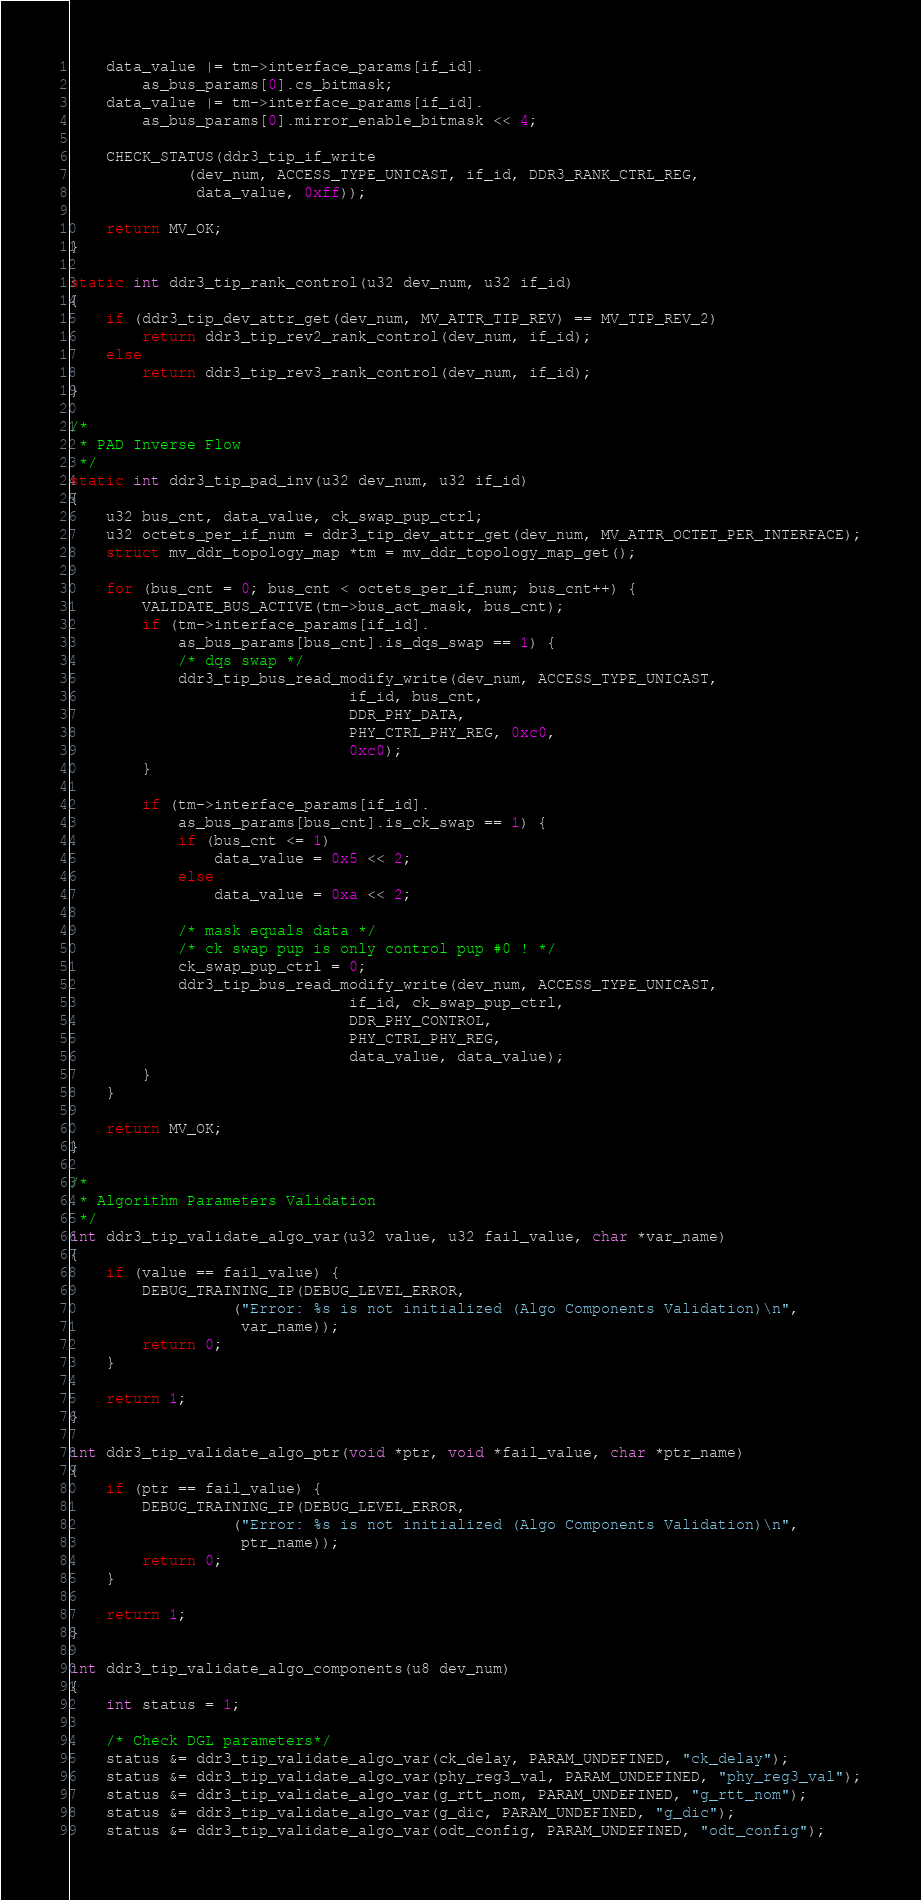<code> <loc_0><loc_0><loc_500><loc_500><_C_>	data_value |= tm->interface_params[if_id].
		as_bus_params[0].cs_bitmask;
	data_value |= tm->interface_params[if_id].
		as_bus_params[0].mirror_enable_bitmask << 4;

	CHECK_STATUS(ddr3_tip_if_write
		     (dev_num, ACCESS_TYPE_UNICAST, if_id, DDR3_RANK_CTRL_REG,
		      data_value, 0xff));

	return MV_OK;
}

static int ddr3_tip_rank_control(u32 dev_num, u32 if_id)
{
	if (ddr3_tip_dev_attr_get(dev_num, MV_ATTR_TIP_REV) == MV_TIP_REV_2)
		return ddr3_tip_rev2_rank_control(dev_num, if_id);
	else
		return ddr3_tip_rev3_rank_control(dev_num, if_id);
}

/*
 * PAD Inverse Flow
 */
static int ddr3_tip_pad_inv(u32 dev_num, u32 if_id)
{
	u32 bus_cnt, data_value, ck_swap_pup_ctrl;
	u32 octets_per_if_num = ddr3_tip_dev_attr_get(dev_num, MV_ATTR_OCTET_PER_INTERFACE);
	struct mv_ddr_topology_map *tm = mv_ddr_topology_map_get();

	for (bus_cnt = 0; bus_cnt < octets_per_if_num; bus_cnt++) {
		VALIDATE_BUS_ACTIVE(tm->bus_act_mask, bus_cnt);
		if (tm->interface_params[if_id].
		    as_bus_params[bus_cnt].is_dqs_swap == 1) {
			/* dqs swap */
			ddr3_tip_bus_read_modify_write(dev_num, ACCESS_TYPE_UNICAST,
						       if_id, bus_cnt,
						       DDR_PHY_DATA,
						       PHY_CTRL_PHY_REG, 0xc0,
						       0xc0);
		}

		if (tm->interface_params[if_id].
		    as_bus_params[bus_cnt].is_ck_swap == 1) {
			if (bus_cnt <= 1)
				data_value = 0x5 << 2;
			else
				data_value = 0xa << 2;

			/* mask equals data */
			/* ck swap pup is only control pup #0 ! */
			ck_swap_pup_ctrl = 0;
			ddr3_tip_bus_read_modify_write(dev_num, ACCESS_TYPE_UNICAST,
						       if_id, ck_swap_pup_ctrl,
						       DDR_PHY_CONTROL,
						       PHY_CTRL_PHY_REG,
						       data_value, data_value);
		}
	}

	return MV_OK;
}

/*
 * Algorithm Parameters Validation
 */
int ddr3_tip_validate_algo_var(u32 value, u32 fail_value, char *var_name)
{
	if (value == fail_value) {
		DEBUG_TRAINING_IP(DEBUG_LEVEL_ERROR,
				  ("Error: %s is not initialized (Algo Components Validation)\n",
				   var_name));
		return 0;
	}

	return 1;
}

int ddr3_tip_validate_algo_ptr(void *ptr, void *fail_value, char *ptr_name)
{
	if (ptr == fail_value) {
		DEBUG_TRAINING_IP(DEBUG_LEVEL_ERROR,
				  ("Error: %s is not initialized (Algo Components Validation)\n",
				   ptr_name));
		return 0;
	}

	return 1;
}

int ddr3_tip_validate_algo_components(u8 dev_num)
{
	int status = 1;

	/* Check DGL parameters*/
	status &= ddr3_tip_validate_algo_var(ck_delay, PARAM_UNDEFINED, "ck_delay");
	status &= ddr3_tip_validate_algo_var(phy_reg3_val, PARAM_UNDEFINED, "phy_reg3_val");
	status &= ddr3_tip_validate_algo_var(g_rtt_nom, PARAM_UNDEFINED, "g_rtt_nom");
	status &= ddr3_tip_validate_algo_var(g_dic, PARAM_UNDEFINED, "g_dic");
	status &= ddr3_tip_validate_algo_var(odt_config, PARAM_UNDEFINED, "odt_config");</code> 